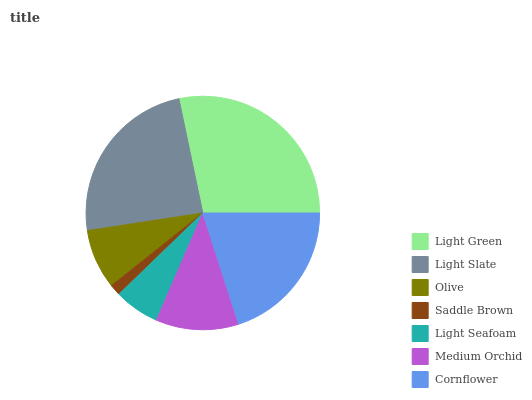Is Saddle Brown the minimum?
Answer yes or no. Yes. Is Light Green the maximum?
Answer yes or no. Yes. Is Light Slate the minimum?
Answer yes or no. No. Is Light Slate the maximum?
Answer yes or no. No. Is Light Green greater than Light Slate?
Answer yes or no. Yes. Is Light Slate less than Light Green?
Answer yes or no. Yes. Is Light Slate greater than Light Green?
Answer yes or no. No. Is Light Green less than Light Slate?
Answer yes or no. No. Is Medium Orchid the high median?
Answer yes or no. Yes. Is Medium Orchid the low median?
Answer yes or no. Yes. Is Olive the high median?
Answer yes or no. No. Is Cornflower the low median?
Answer yes or no. No. 